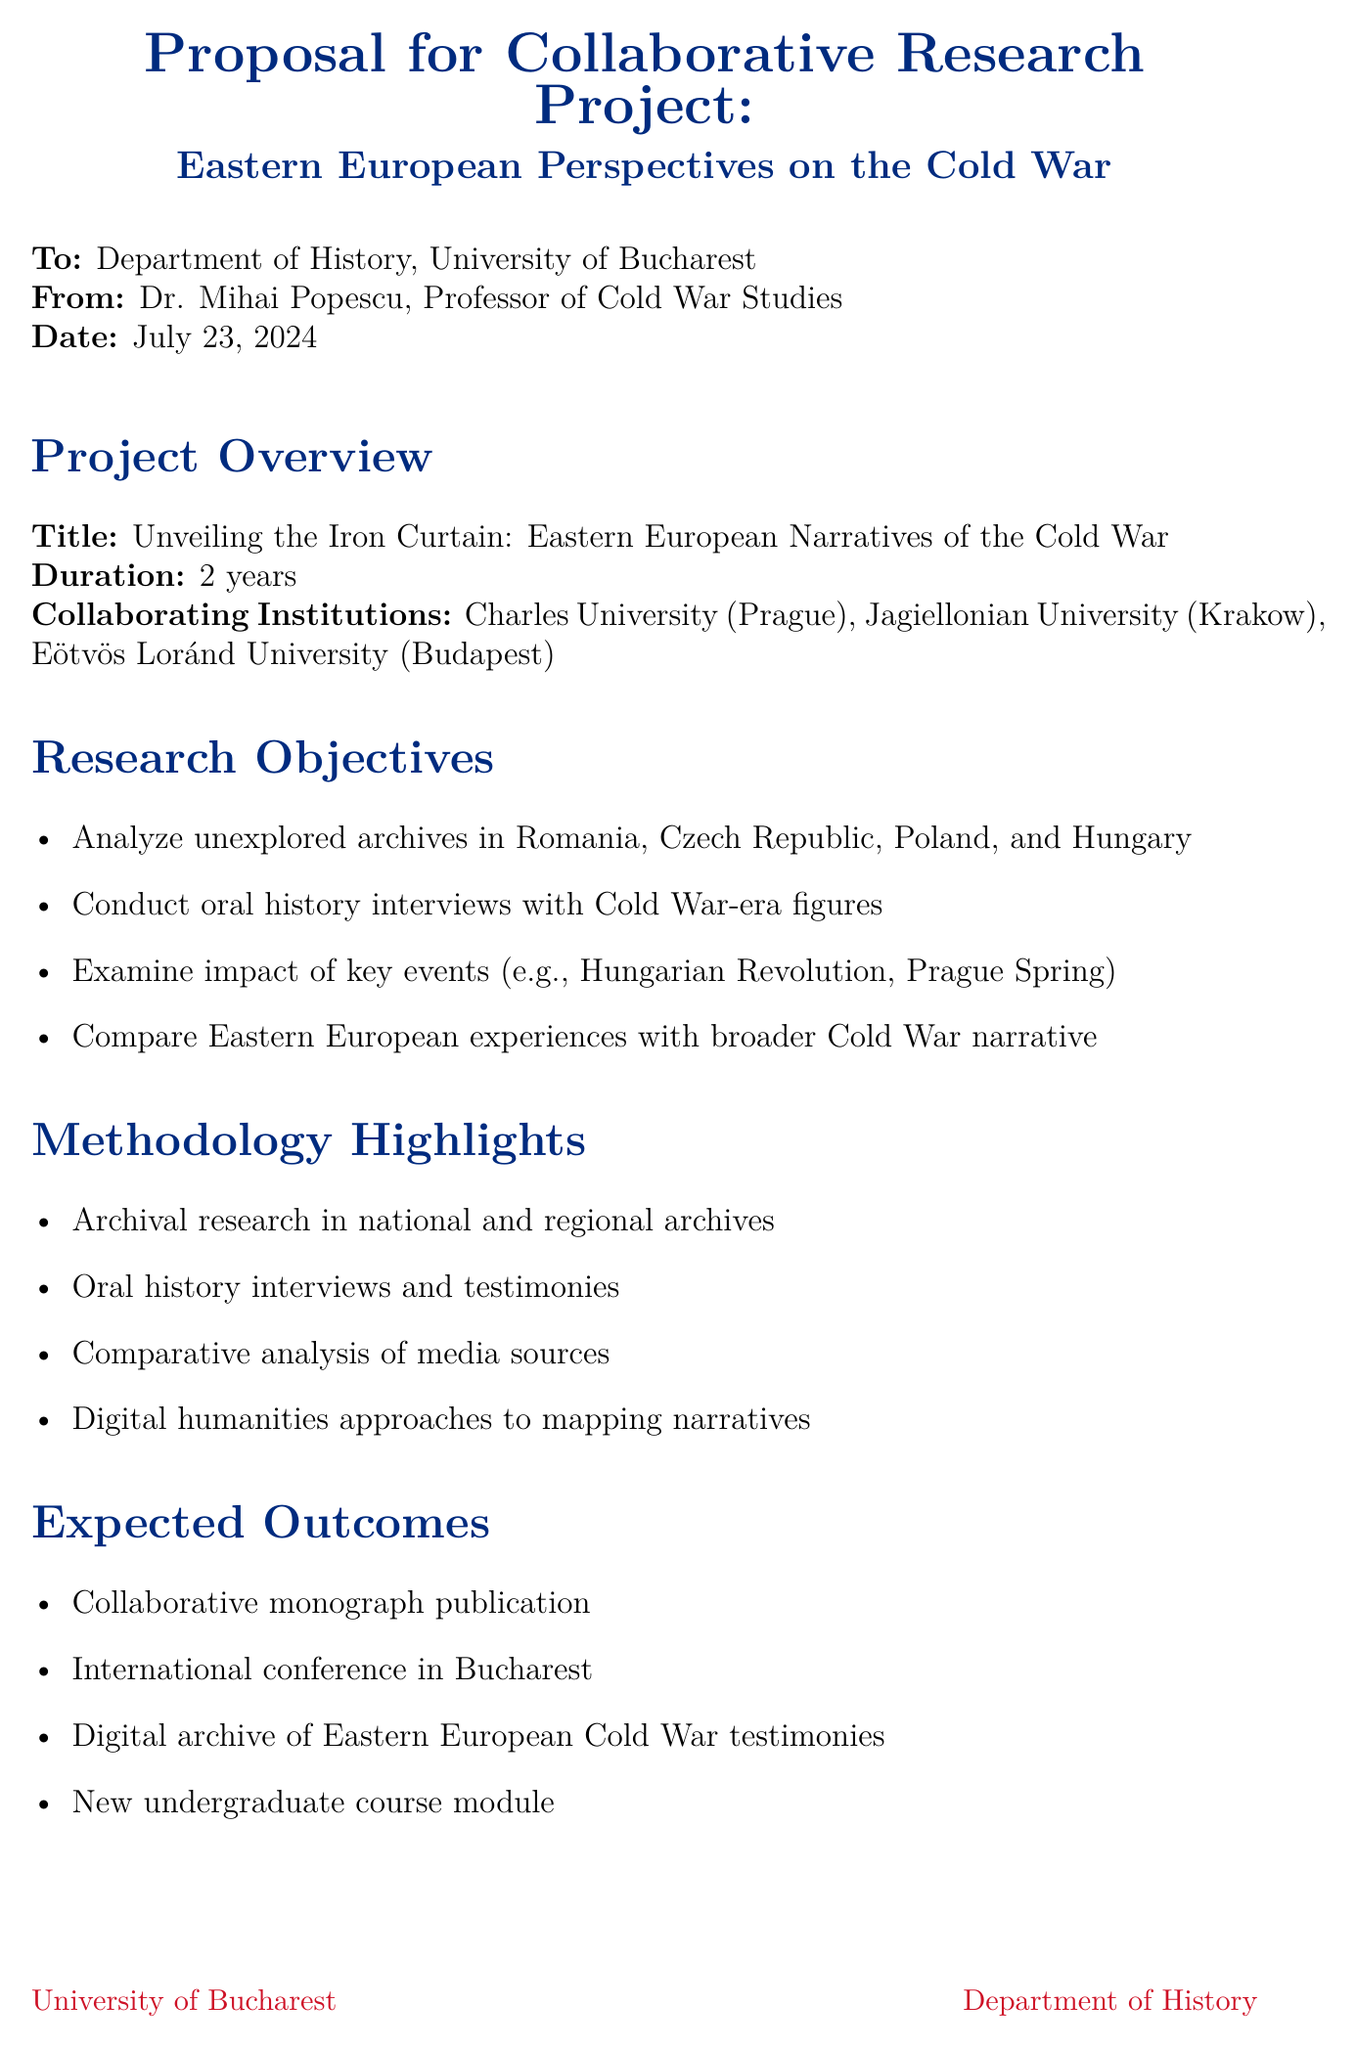What is the title of the project? The title is specified in the project overview section of the document.
Answer: Unveiling the Iron Curtain: Eastern European Narratives of the Cold War What is the duration of the project? The duration of the project is mentioned in the project overview section.
Answer: 2 years Which universities are collaborating on this project? The collaborating institutions are listed in the project overview section.
Answer: Charles University, Jagiellonian University, Eötvös Loránd University What is the total budget estimate for the project? The budget estimate is provided in the budget estimate section of the document.
Answer: €250,000 Name one of the research objectives. Research objectives are enumerated, and any of them can be considered.
Answer: Analyze previously unexplored archives in Romania, Czech Republic, Poland, and Hungary What event will be examined for its impact on local perspectives? The document mentions key events in the research objectives.
Answer: Hungarian Revolution of 1956 What is one expected outcome of the project? Expected outcomes are listed in the respective section of the document.
Answer: Publication of a collaborative monograph Which potential funding source is mentioned? Potential funding sources are specified in the funding section of the memo.
Answer: European Research Council (ERC) Consolidator Grant What is the significance of the project to Romanian history? The relevance to Romanian history is highlighted in a dedicated section.
Answer: Illuminating Romania's unique position between the Warsaw Pact and an independent foreign policy 